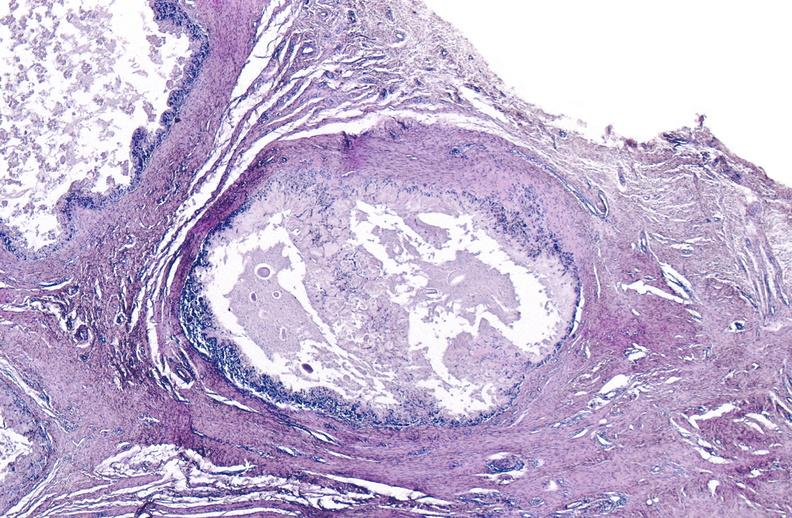what is present?
Answer the question using a single word or phrase. Joints 